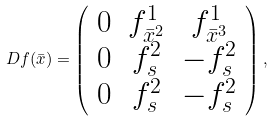Convert formula to latex. <formula><loc_0><loc_0><loc_500><loc_500>D f ( \bar { x } ) = \left ( \begin{array} { c c c } 0 & f ^ { 1 } _ { \bar { x } ^ { 2 } } & f ^ { 1 } _ { \bar { x } ^ { 3 } } \\ 0 & f ^ { 2 } _ { s } & - f ^ { 2 } _ { s } \\ 0 & f ^ { 2 } _ { s } & - f ^ { 2 } _ { s } \end{array} \right ) ,</formula> 